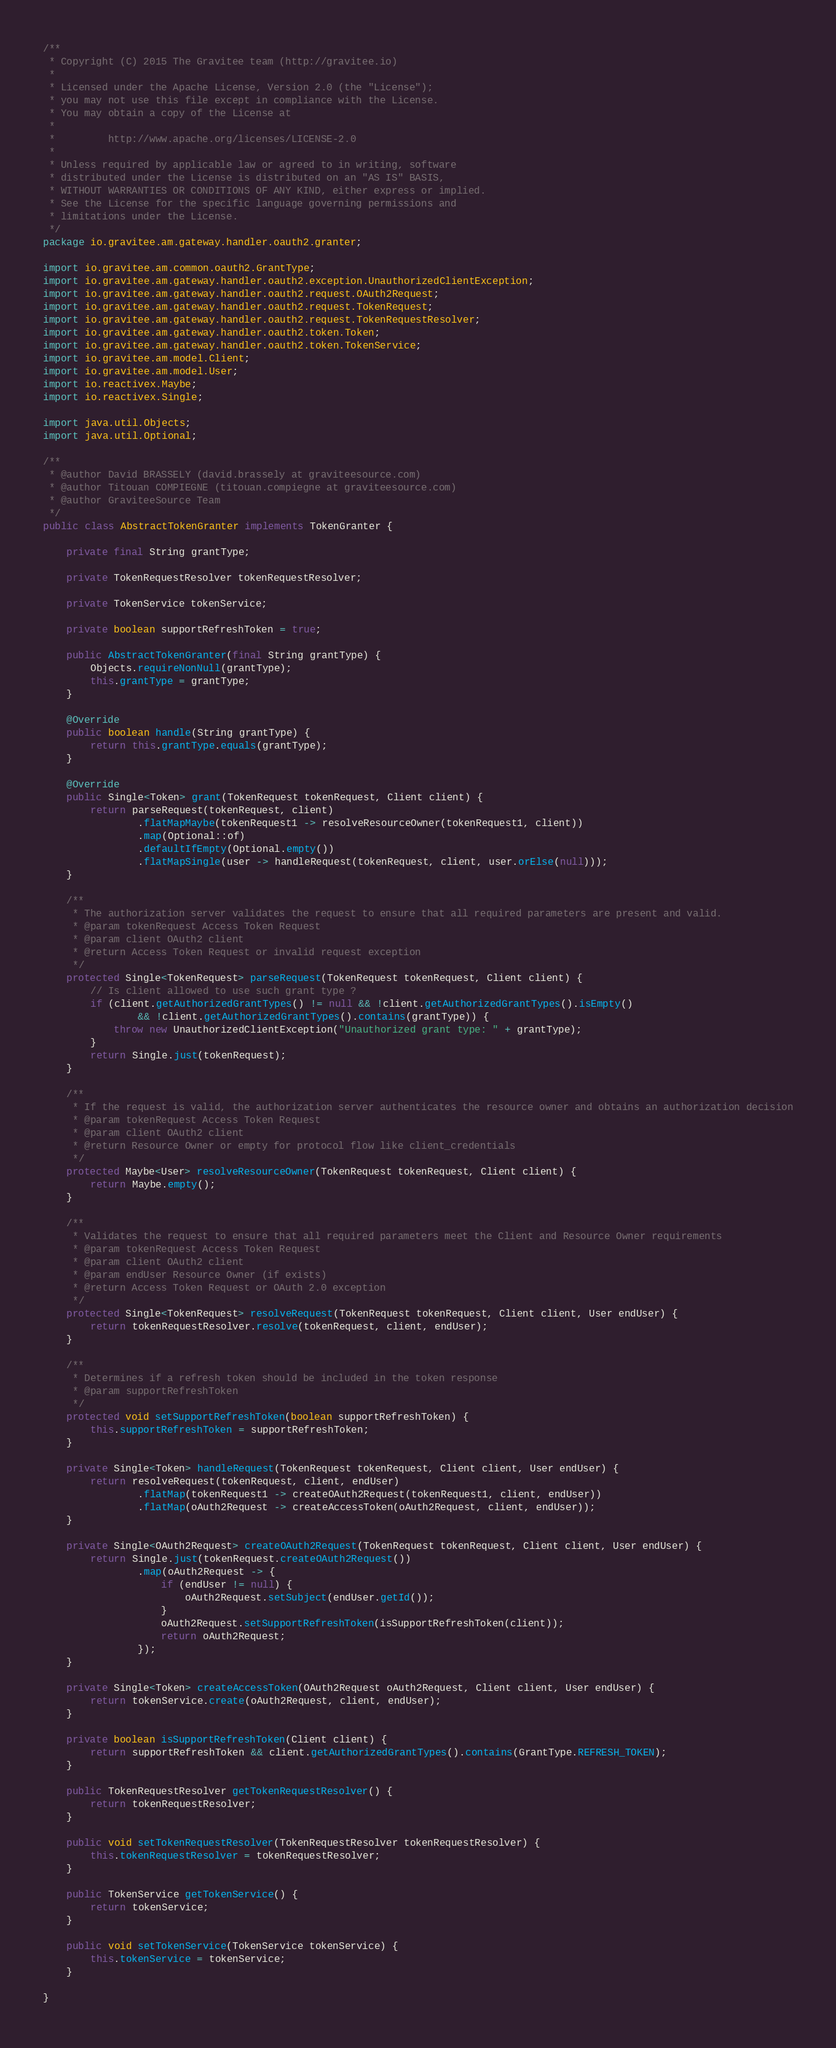Convert code to text. <code><loc_0><loc_0><loc_500><loc_500><_Java_>/**
 * Copyright (C) 2015 The Gravitee team (http://gravitee.io)
 *
 * Licensed under the Apache License, Version 2.0 (the "License");
 * you may not use this file except in compliance with the License.
 * You may obtain a copy of the License at
 *
 *         http://www.apache.org/licenses/LICENSE-2.0
 *
 * Unless required by applicable law or agreed to in writing, software
 * distributed under the License is distributed on an "AS IS" BASIS,
 * WITHOUT WARRANTIES OR CONDITIONS OF ANY KIND, either express or implied.
 * See the License for the specific language governing permissions and
 * limitations under the License.
 */
package io.gravitee.am.gateway.handler.oauth2.granter;

import io.gravitee.am.common.oauth2.GrantType;
import io.gravitee.am.gateway.handler.oauth2.exception.UnauthorizedClientException;
import io.gravitee.am.gateway.handler.oauth2.request.OAuth2Request;
import io.gravitee.am.gateway.handler.oauth2.request.TokenRequest;
import io.gravitee.am.gateway.handler.oauth2.request.TokenRequestResolver;
import io.gravitee.am.gateway.handler.oauth2.token.Token;
import io.gravitee.am.gateway.handler.oauth2.token.TokenService;
import io.gravitee.am.model.Client;
import io.gravitee.am.model.User;
import io.reactivex.Maybe;
import io.reactivex.Single;

import java.util.Objects;
import java.util.Optional;

/**
 * @author David BRASSELY (david.brassely at graviteesource.com)
 * @author Titouan COMPIEGNE (titouan.compiegne at graviteesource.com)
 * @author GraviteeSource Team
 */
public class AbstractTokenGranter implements TokenGranter {

    private final String grantType;

    private TokenRequestResolver tokenRequestResolver;

    private TokenService tokenService;

    private boolean supportRefreshToken = true;

    public AbstractTokenGranter(final String grantType) {
        Objects.requireNonNull(grantType);
        this.grantType = grantType;
    }

    @Override
    public boolean handle(String grantType) {
        return this.grantType.equals(grantType);
    }

    @Override
    public Single<Token> grant(TokenRequest tokenRequest, Client client) {
        return parseRequest(tokenRequest, client)
                .flatMapMaybe(tokenRequest1 -> resolveResourceOwner(tokenRequest1, client))
                .map(Optional::of)
                .defaultIfEmpty(Optional.empty())
                .flatMapSingle(user -> handleRequest(tokenRequest, client, user.orElse(null)));
    }

    /**
     * The authorization server validates the request to ensure that all required parameters are present and valid.
     * @param tokenRequest Access Token Request
     * @param client OAuth2 client
     * @return Access Token Request or invalid request exception
     */
    protected Single<TokenRequest> parseRequest(TokenRequest tokenRequest, Client client) {
        // Is client allowed to use such grant type ?
        if (client.getAuthorizedGrantTypes() != null && !client.getAuthorizedGrantTypes().isEmpty()
                && !client.getAuthorizedGrantTypes().contains(grantType)) {
            throw new UnauthorizedClientException("Unauthorized grant type: " + grantType);
        }
        return Single.just(tokenRequest);
    }

    /**
     * If the request is valid, the authorization server authenticates the resource owner and obtains an authorization decision
     * @param tokenRequest Access Token Request
     * @param client OAuth2 client
     * @return Resource Owner or empty for protocol flow like client_credentials
     */
    protected Maybe<User> resolveResourceOwner(TokenRequest tokenRequest, Client client) {
        return Maybe.empty();
    }

    /**
     * Validates the request to ensure that all required parameters meet the Client and Resource Owner requirements
     * @param tokenRequest Access Token Request
     * @param client OAuth2 client
     * @param endUser Resource Owner (if exists)
     * @return Access Token Request or OAuth 2.0 exception
     */
    protected Single<TokenRequest> resolveRequest(TokenRequest tokenRequest, Client client, User endUser) {
        return tokenRequestResolver.resolve(tokenRequest, client, endUser);
    }

    /**
     * Determines if a refresh token should be included in the token response
     * @param supportRefreshToken
     */
    protected void setSupportRefreshToken(boolean supportRefreshToken) {
        this.supportRefreshToken = supportRefreshToken;
    }

    private Single<Token> handleRequest(TokenRequest tokenRequest, Client client, User endUser) {
        return resolveRequest(tokenRequest, client, endUser)
                .flatMap(tokenRequest1 -> createOAuth2Request(tokenRequest1, client, endUser))
                .flatMap(oAuth2Request -> createAccessToken(oAuth2Request, client, endUser));
    }

    private Single<OAuth2Request> createOAuth2Request(TokenRequest tokenRequest, Client client, User endUser) {
        return Single.just(tokenRequest.createOAuth2Request())
                .map(oAuth2Request -> {
                    if (endUser != null) {
                        oAuth2Request.setSubject(endUser.getId());
                    }
                    oAuth2Request.setSupportRefreshToken(isSupportRefreshToken(client));
                    return oAuth2Request;
                });
    }

    private Single<Token> createAccessToken(OAuth2Request oAuth2Request, Client client, User endUser) {
        return tokenService.create(oAuth2Request, client, endUser);
    }

    private boolean isSupportRefreshToken(Client client) {
        return supportRefreshToken && client.getAuthorizedGrantTypes().contains(GrantType.REFRESH_TOKEN);
    }

    public TokenRequestResolver getTokenRequestResolver() {
        return tokenRequestResolver;
    }

    public void setTokenRequestResolver(TokenRequestResolver tokenRequestResolver) {
        this.tokenRequestResolver = tokenRequestResolver;
    }

    public TokenService getTokenService() {
        return tokenService;
    }

    public void setTokenService(TokenService tokenService) {
        this.tokenService = tokenService;
    }

}
</code> 